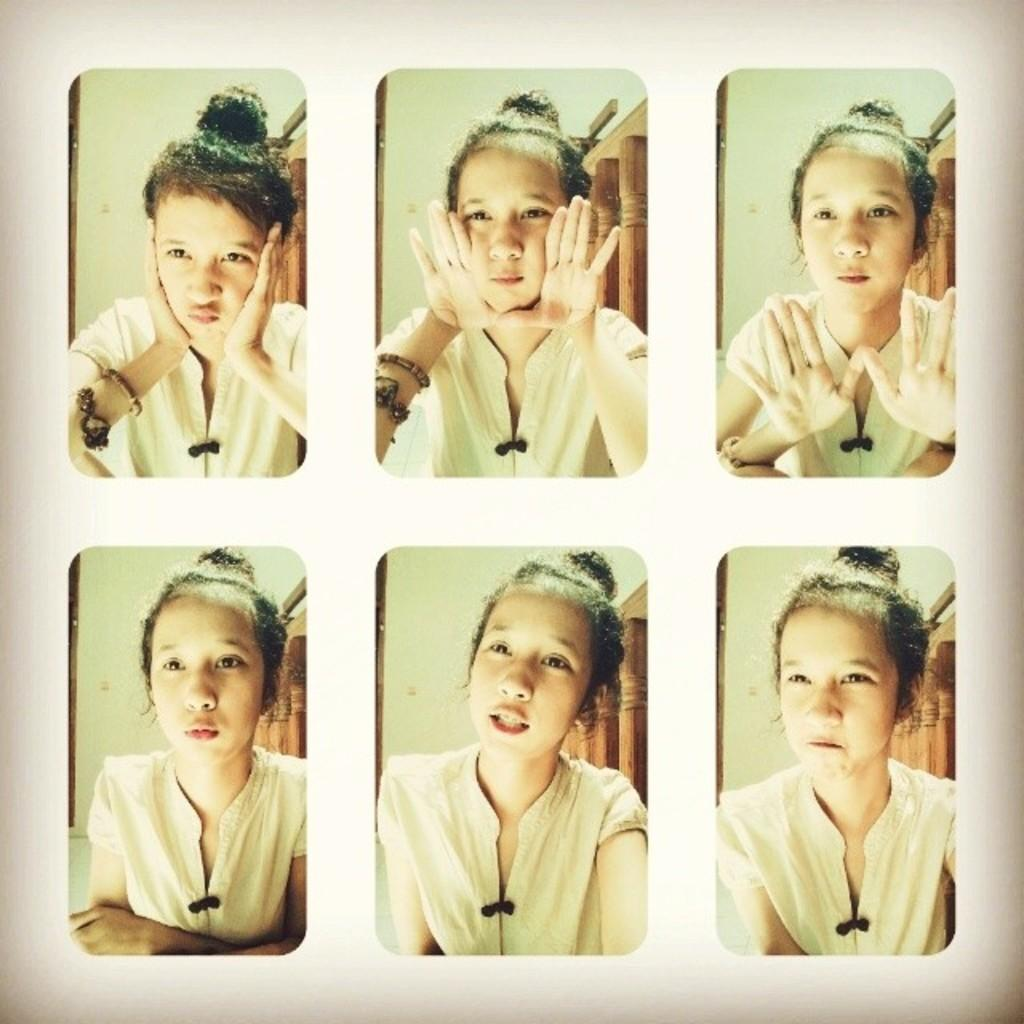What is the main subject of the image? The main subject of the image is a woman. Can you describe the woman's face expressions in the image? The woman has different face expressions in the image. What can be seen in the background of the image? There is a wall in the image. What type of game is the woman playing in the image? There is no game present in the image; it features a woman with different face expressions and a wall in the background. How many beds are visible in the image? There are no beds visible in the image. 